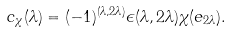Convert formula to latex. <formula><loc_0><loc_0><loc_500><loc_500>c _ { \chi } ( \lambda ) = ( - 1 ) ^ { ( \lambda , 2 \lambda ) } \epsilon ( \lambda , 2 \lambda ) \chi ( e _ { 2 \lambda } ) .</formula> 